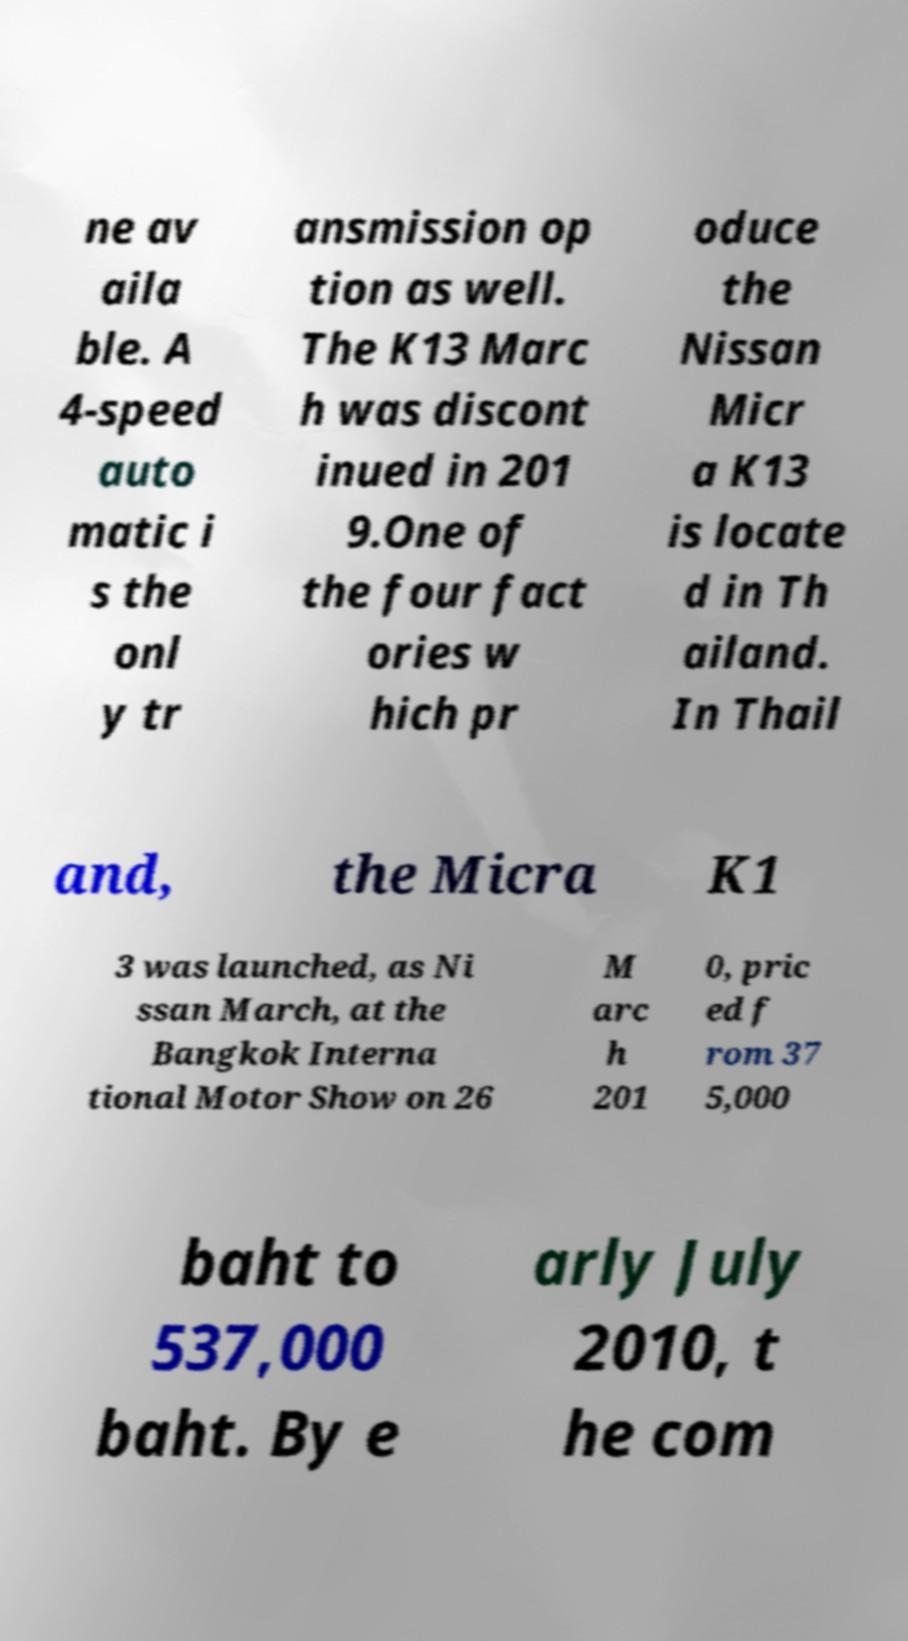Please identify and transcribe the text found in this image. ne av aila ble. A 4-speed auto matic i s the onl y tr ansmission op tion as well. The K13 Marc h was discont inued in 201 9.One of the four fact ories w hich pr oduce the Nissan Micr a K13 is locate d in Th ailand. In Thail and, the Micra K1 3 was launched, as Ni ssan March, at the Bangkok Interna tional Motor Show on 26 M arc h 201 0, pric ed f rom 37 5,000 baht to 537,000 baht. By e arly July 2010, t he com 